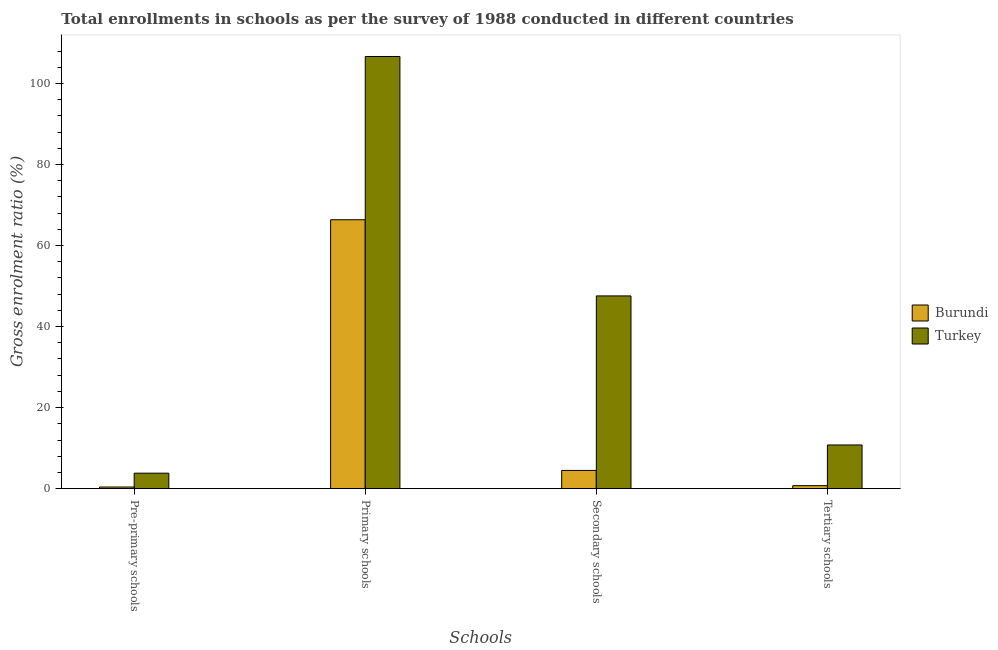How many different coloured bars are there?
Provide a short and direct response. 2. How many bars are there on the 3rd tick from the left?
Offer a very short reply. 2. How many bars are there on the 1st tick from the right?
Make the answer very short. 2. What is the label of the 1st group of bars from the left?
Offer a very short reply. Pre-primary schools. What is the gross enrolment ratio in primary schools in Burundi?
Your response must be concise. 66.36. Across all countries, what is the maximum gross enrolment ratio in tertiary schools?
Offer a very short reply. 10.79. Across all countries, what is the minimum gross enrolment ratio in secondary schools?
Provide a short and direct response. 4.5. In which country was the gross enrolment ratio in tertiary schools maximum?
Provide a short and direct response. Turkey. In which country was the gross enrolment ratio in tertiary schools minimum?
Keep it short and to the point. Burundi. What is the total gross enrolment ratio in secondary schools in the graph?
Keep it short and to the point. 52.07. What is the difference between the gross enrolment ratio in secondary schools in Burundi and that in Turkey?
Offer a very short reply. -43.06. What is the difference between the gross enrolment ratio in tertiary schools in Turkey and the gross enrolment ratio in primary schools in Burundi?
Offer a terse response. -55.58. What is the average gross enrolment ratio in tertiary schools per country?
Make the answer very short. 5.76. What is the difference between the gross enrolment ratio in secondary schools and gross enrolment ratio in pre-primary schools in Burundi?
Provide a short and direct response. 4.09. In how many countries, is the gross enrolment ratio in tertiary schools greater than 100 %?
Your answer should be very brief. 0. What is the ratio of the gross enrolment ratio in pre-primary schools in Burundi to that in Turkey?
Provide a succinct answer. 0.11. Is the difference between the gross enrolment ratio in primary schools in Burundi and Turkey greater than the difference between the gross enrolment ratio in pre-primary schools in Burundi and Turkey?
Your response must be concise. No. What is the difference between the highest and the second highest gross enrolment ratio in tertiary schools?
Provide a short and direct response. 10.04. What is the difference between the highest and the lowest gross enrolment ratio in pre-primary schools?
Give a very brief answer. 3.41. In how many countries, is the gross enrolment ratio in primary schools greater than the average gross enrolment ratio in primary schools taken over all countries?
Make the answer very short. 1. Is it the case that in every country, the sum of the gross enrolment ratio in secondary schools and gross enrolment ratio in pre-primary schools is greater than the sum of gross enrolment ratio in tertiary schools and gross enrolment ratio in primary schools?
Provide a short and direct response. Yes. What does the 2nd bar from the left in Secondary schools represents?
Provide a short and direct response. Turkey. Is it the case that in every country, the sum of the gross enrolment ratio in pre-primary schools and gross enrolment ratio in primary schools is greater than the gross enrolment ratio in secondary schools?
Provide a short and direct response. Yes. What is the difference between two consecutive major ticks on the Y-axis?
Your answer should be very brief. 20. Does the graph contain any zero values?
Provide a succinct answer. No. Does the graph contain grids?
Provide a succinct answer. No. Where does the legend appear in the graph?
Offer a terse response. Center right. What is the title of the graph?
Your answer should be very brief. Total enrollments in schools as per the survey of 1988 conducted in different countries. Does "Moldova" appear as one of the legend labels in the graph?
Provide a succinct answer. No. What is the label or title of the X-axis?
Offer a terse response. Schools. What is the Gross enrolment ratio (%) of Burundi in Pre-primary schools?
Offer a terse response. 0.41. What is the Gross enrolment ratio (%) of Turkey in Pre-primary schools?
Provide a succinct answer. 3.82. What is the Gross enrolment ratio (%) in Burundi in Primary schools?
Make the answer very short. 66.36. What is the Gross enrolment ratio (%) of Turkey in Primary schools?
Your answer should be compact. 106.65. What is the Gross enrolment ratio (%) in Burundi in Secondary schools?
Offer a terse response. 4.5. What is the Gross enrolment ratio (%) in Turkey in Secondary schools?
Ensure brevity in your answer.  47.57. What is the Gross enrolment ratio (%) of Burundi in Tertiary schools?
Ensure brevity in your answer.  0.74. What is the Gross enrolment ratio (%) of Turkey in Tertiary schools?
Your response must be concise. 10.79. Across all Schools, what is the maximum Gross enrolment ratio (%) of Burundi?
Give a very brief answer. 66.36. Across all Schools, what is the maximum Gross enrolment ratio (%) of Turkey?
Your answer should be very brief. 106.65. Across all Schools, what is the minimum Gross enrolment ratio (%) of Burundi?
Ensure brevity in your answer.  0.41. Across all Schools, what is the minimum Gross enrolment ratio (%) of Turkey?
Your response must be concise. 3.82. What is the total Gross enrolment ratio (%) in Burundi in the graph?
Offer a very short reply. 72.02. What is the total Gross enrolment ratio (%) of Turkey in the graph?
Your answer should be compact. 168.82. What is the difference between the Gross enrolment ratio (%) in Burundi in Pre-primary schools and that in Primary schools?
Your response must be concise. -65.95. What is the difference between the Gross enrolment ratio (%) of Turkey in Pre-primary schools and that in Primary schools?
Give a very brief answer. -102.83. What is the difference between the Gross enrolment ratio (%) in Burundi in Pre-primary schools and that in Secondary schools?
Provide a short and direct response. -4.09. What is the difference between the Gross enrolment ratio (%) of Turkey in Pre-primary schools and that in Secondary schools?
Make the answer very short. -43.74. What is the difference between the Gross enrolment ratio (%) of Burundi in Pre-primary schools and that in Tertiary schools?
Ensure brevity in your answer.  -0.33. What is the difference between the Gross enrolment ratio (%) of Turkey in Pre-primary schools and that in Tertiary schools?
Make the answer very short. -6.96. What is the difference between the Gross enrolment ratio (%) of Burundi in Primary schools and that in Secondary schools?
Your answer should be very brief. 61.86. What is the difference between the Gross enrolment ratio (%) in Turkey in Primary schools and that in Secondary schools?
Ensure brevity in your answer.  59.08. What is the difference between the Gross enrolment ratio (%) in Burundi in Primary schools and that in Tertiary schools?
Keep it short and to the point. 65.62. What is the difference between the Gross enrolment ratio (%) in Turkey in Primary schools and that in Tertiary schools?
Provide a short and direct response. 95.86. What is the difference between the Gross enrolment ratio (%) in Burundi in Secondary schools and that in Tertiary schools?
Your response must be concise. 3.76. What is the difference between the Gross enrolment ratio (%) in Turkey in Secondary schools and that in Tertiary schools?
Your response must be concise. 36.78. What is the difference between the Gross enrolment ratio (%) of Burundi in Pre-primary schools and the Gross enrolment ratio (%) of Turkey in Primary schools?
Give a very brief answer. -106.24. What is the difference between the Gross enrolment ratio (%) in Burundi in Pre-primary schools and the Gross enrolment ratio (%) in Turkey in Secondary schools?
Offer a very short reply. -47.16. What is the difference between the Gross enrolment ratio (%) in Burundi in Pre-primary schools and the Gross enrolment ratio (%) in Turkey in Tertiary schools?
Your answer should be very brief. -10.38. What is the difference between the Gross enrolment ratio (%) in Burundi in Primary schools and the Gross enrolment ratio (%) in Turkey in Secondary schools?
Your response must be concise. 18.8. What is the difference between the Gross enrolment ratio (%) of Burundi in Primary schools and the Gross enrolment ratio (%) of Turkey in Tertiary schools?
Provide a succinct answer. 55.58. What is the difference between the Gross enrolment ratio (%) of Burundi in Secondary schools and the Gross enrolment ratio (%) of Turkey in Tertiary schools?
Give a very brief answer. -6.28. What is the average Gross enrolment ratio (%) in Burundi per Schools?
Ensure brevity in your answer.  18. What is the average Gross enrolment ratio (%) in Turkey per Schools?
Provide a short and direct response. 42.2. What is the difference between the Gross enrolment ratio (%) in Burundi and Gross enrolment ratio (%) in Turkey in Pre-primary schools?
Provide a succinct answer. -3.41. What is the difference between the Gross enrolment ratio (%) in Burundi and Gross enrolment ratio (%) in Turkey in Primary schools?
Give a very brief answer. -40.28. What is the difference between the Gross enrolment ratio (%) in Burundi and Gross enrolment ratio (%) in Turkey in Secondary schools?
Your answer should be compact. -43.06. What is the difference between the Gross enrolment ratio (%) of Burundi and Gross enrolment ratio (%) of Turkey in Tertiary schools?
Provide a short and direct response. -10.04. What is the ratio of the Gross enrolment ratio (%) in Burundi in Pre-primary schools to that in Primary schools?
Give a very brief answer. 0.01. What is the ratio of the Gross enrolment ratio (%) of Turkey in Pre-primary schools to that in Primary schools?
Your answer should be very brief. 0.04. What is the ratio of the Gross enrolment ratio (%) in Burundi in Pre-primary schools to that in Secondary schools?
Your response must be concise. 0.09. What is the ratio of the Gross enrolment ratio (%) in Turkey in Pre-primary schools to that in Secondary schools?
Make the answer very short. 0.08. What is the ratio of the Gross enrolment ratio (%) in Burundi in Pre-primary schools to that in Tertiary schools?
Your answer should be compact. 0.55. What is the ratio of the Gross enrolment ratio (%) in Turkey in Pre-primary schools to that in Tertiary schools?
Provide a short and direct response. 0.35. What is the ratio of the Gross enrolment ratio (%) of Burundi in Primary schools to that in Secondary schools?
Provide a short and direct response. 14.74. What is the ratio of the Gross enrolment ratio (%) in Turkey in Primary schools to that in Secondary schools?
Ensure brevity in your answer.  2.24. What is the ratio of the Gross enrolment ratio (%) of Burundi in Primary schools to that in Tertiary schools?
Offer a terse response. 89.32. What is the ratio of the Gross enrolment ratio (%) of Turkey in Primary schools to that in Tertiary schools?
Provide a succinct answer. 9.89. What is the ratio of the Gross enrolment ratio (%) in Burundi in Secondary schools to that in Tertiary schools?
Provide a succinct answer. 6.06. What is the ratio of the Gross enrolment ratio (%) in Turkey in Secondary schools to that in Tertiary schools?
Provide a succinct answer. 4.41. What is the difference between the highest and the second highest Gross enrolment ratio (%) in Burundi?
Your answer should be compact. 61.86. What is the difference between the highest and the second highest Gross enrolment ratio (%) in Turkey?
Make the answer very short. 59.08. What is the difference between the highest and the lowest Gross enrolment ratio (%) of Burundi?
Give a very brief answer. 65.95. What is the difference between the highest and the lowest Gross enrolment ratio (%) in Turkey?
Your response must be concise. 102.83. 